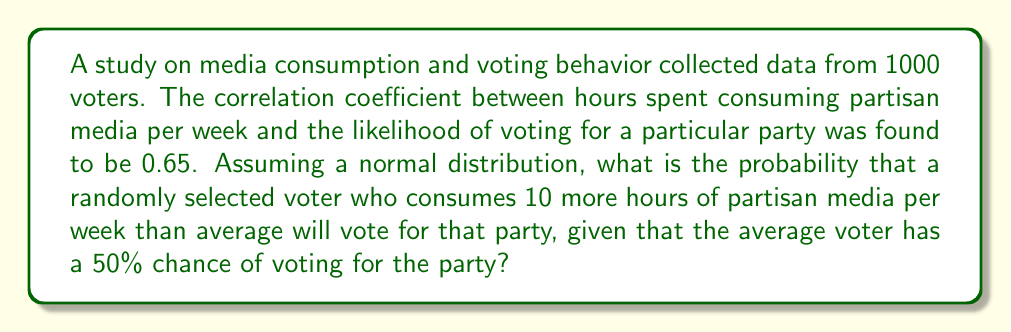Could you help me with this problem? To solve this problem, we'll use concepts from statistical mechanics and probability theory:

1) The correlation coefficient $r = 0.65$ indicates a moderately strong positive relationship between partisan media consumption and voting behavior.

2) We can use the concept of a standard normal distribution to calculate the probability.

3) First, we need to convert the correlation coefficient to a z-score. In a bivariate normal distribution, the expected value of Y given X is:

   $$E(Y|X) = \mu_Y + r\frac{\sigma_Y}{\sigma_X}(X - \mu_X)$$

   where $r$ is the correlation coefficient.

4) We don't have information about the standard deviations, so we'll assume they're equal (standardized variables). This simplifies our equation to:

   $$E(Y|X) = \mu_Y + r(X - \mu_X)$$

5) We're told that 10 hours above average consumption is our X value, and the average voter (μ_Y) has a 50% chance of voting for the party.

6) Plugging in our values:

   $$E(Y|X) = 0.50 + 0.65(10) = 0.50 + 6.50 = 7.00$$

7) This means that a voter consuming 10 hours more partisan media than average is 7 standard deviations above the mean in terms of voting likelihood.

8) To find the probability, we need to calculate the area under the standard normal curve above z = 7.

9) Using a standard normal table or calculator, we find:

   $$P(Z > 7) \approx 1.28 \times 10^{-12}$$

10) Therefore, the probability of voting for the party is:

    $$1 - 1.28 \times 10^{-12} \approx 0.999999999999$$
Answer: $\approx 0.999999999999$ or $>99.9999999999\%$ 